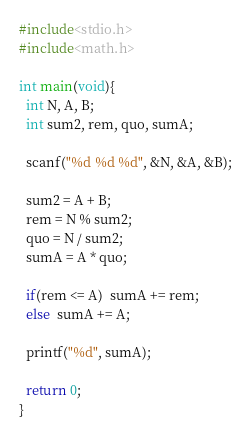<code> <loc_0><loc_0><loc_500><loc_500><_C_>#include<stdio.h>
#include<math.h>

int main(void){
  int N, A, B;
  int sum2, rem, quo, sumA;
  
  scanf("%d %d %d", &N, &A, &B);
  
  sum2 = A + B;
  rem = N % sum2;
  quo = N / sum2;
  sumA = A * quo;
  
  if(rem <= A)  sumA += rem;
  else  sumA += A;
  
  printf("%d", sumA);
  
  return 0;
}</code> 